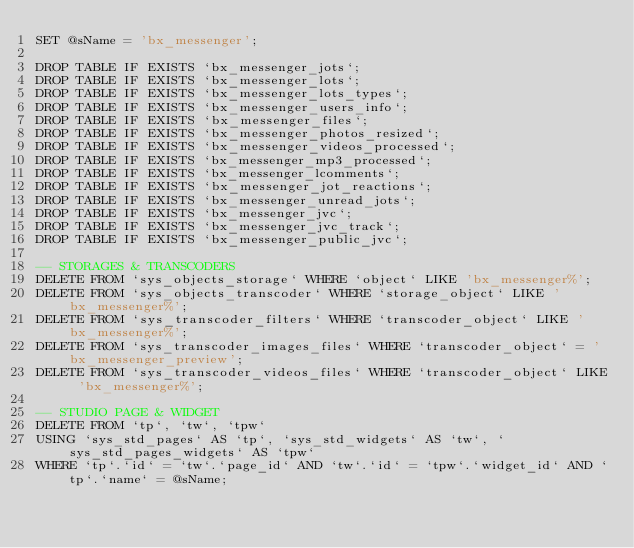Convert code to text. <code><loc_0><loc_0><loc_500><loc_500><_SQL_>SET @sName = 'bx_messenger';

DROP TABLE IF EXISTS `bx_messenger_jots`;
DROP TABLE IF EXISTS `bx_messenger_lots`;
DROP TABLE IF EXISTS `bx_messenger_lots_types`;
DROP TABLE IF EXISTS `bx_messenger_users_info`;
DROP TABLE IF EXISTS `bx_messenger_files`;
DROP TABLE IF EXISTS `bx_messenger_photos_resized`;
DROP TABLE IF EXISTS `bx_messenger_videos_processed`;
DROP TABLE IF EXISTS `bx_messenger_mp3_processed`;
DROP TABLE IF EXISTS `bx_messenger_lcomments`;
DROP TABLE IF EXISTS `bx_messenger_jot_reactions`;
DROP TABLE IF EXISTS `bx_messenger_unread_jots`;
DROP TABLE IF EXISTS `bx_messenger_jvc`;
DROP TABLE IF EXISTS `bx_messenger_jvc_track`;
DROP TABLE IF EXISTS `bx_messenger_public_jvc`;

-- STORAGES & TRANSCODERS
DELETE FROM `sys_objects_storage` WHERE `object` LIKE 'bx_messenger%';
DELETE FROM `sys_objects_transcoder` WHERE `storage_object` LIKE 'bx_messenger%';
DELETE FROM `sys_transcoder_filters` WHERE `transcoder_object` LIKE 'bx_messenger%';
DELETE FROM `sys_transcoder_images_files` WHERE `transcoder_object` = 'bx_messenger_preview';
DELETE FROM `sys_transcoder_videos_files` WHERE `transcoder_object` LIKE 'bx_messenger%';

-- STUDIO PAGE & WIDGET
DELETE FROM `tp`, `tw`, `tpw`
USING `sys_std_pages` AS `tp`, `sys_std_widgets` AS `tw`, `sys_std_pages_widgets` AS `tpw`
WHERE `tp`.`id` = `tw`.`page_id` AND `tw`.`id` = `tpw`.`widget_id` AND `tp`.`name` = @sName;</code> 